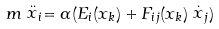Convert formula to latex. <formula><loc_0><loc_0><loc_500><loc_500>m \stackrel { . . } { x } _ { i } = \alpha ( E _ { i } ( x _ { k } ) + F _ { i j } ( x _ { k } ) \stackrel { . } { x } _ { j } )</formula> 